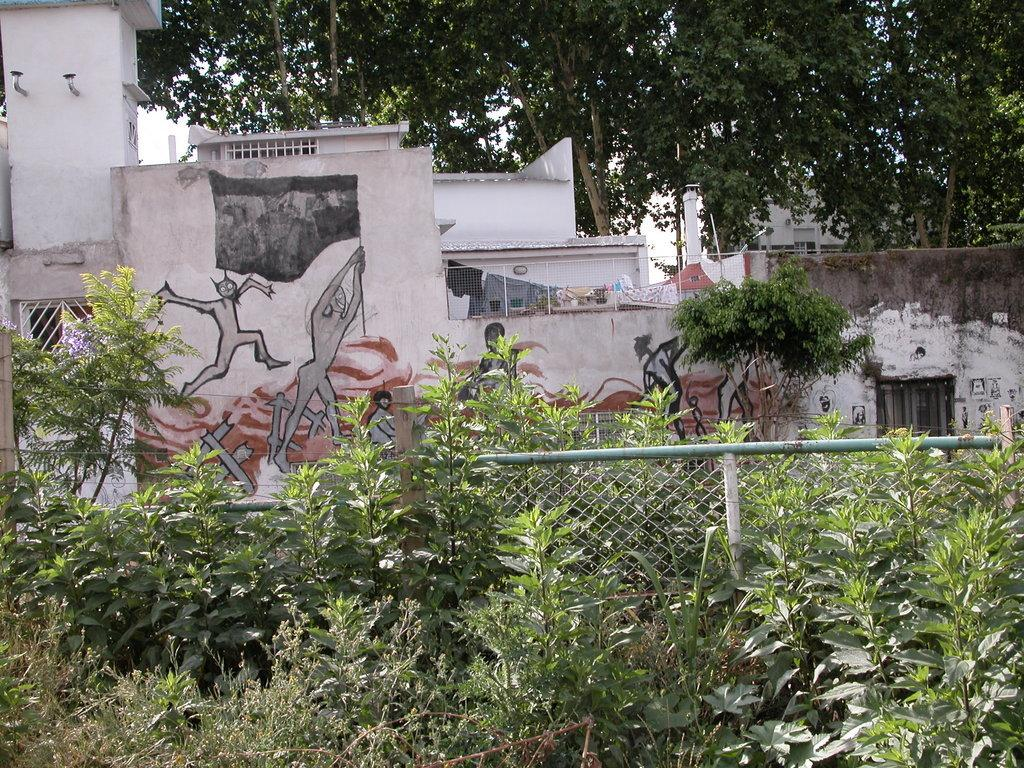What type of living organisms can be seen in the image? Plants can be seen in the image. What is located behind the plants? There is fencing behind the plants. What can be seen in the distance in the image? There are houses and trees in the background of the image. What type of beef is being cooked on the grill in the image? There is no grill or beef present in the image; it features plants, fencing, houses, and trees. How many eyes can be seen on the person in the image? There is no person present in the image, so it is not possible to determine the number of eyes. 